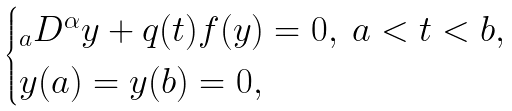<formula> <loc_0><loc_0><loc_500><loc_500>\begin{cases} _ { a } D ^ { \alpha } y + q ( t ) f ( y ) = 0 , \ a < t < b , \\ y ( a ) = y ( b ) = 0 , \end{cases}</formula> 